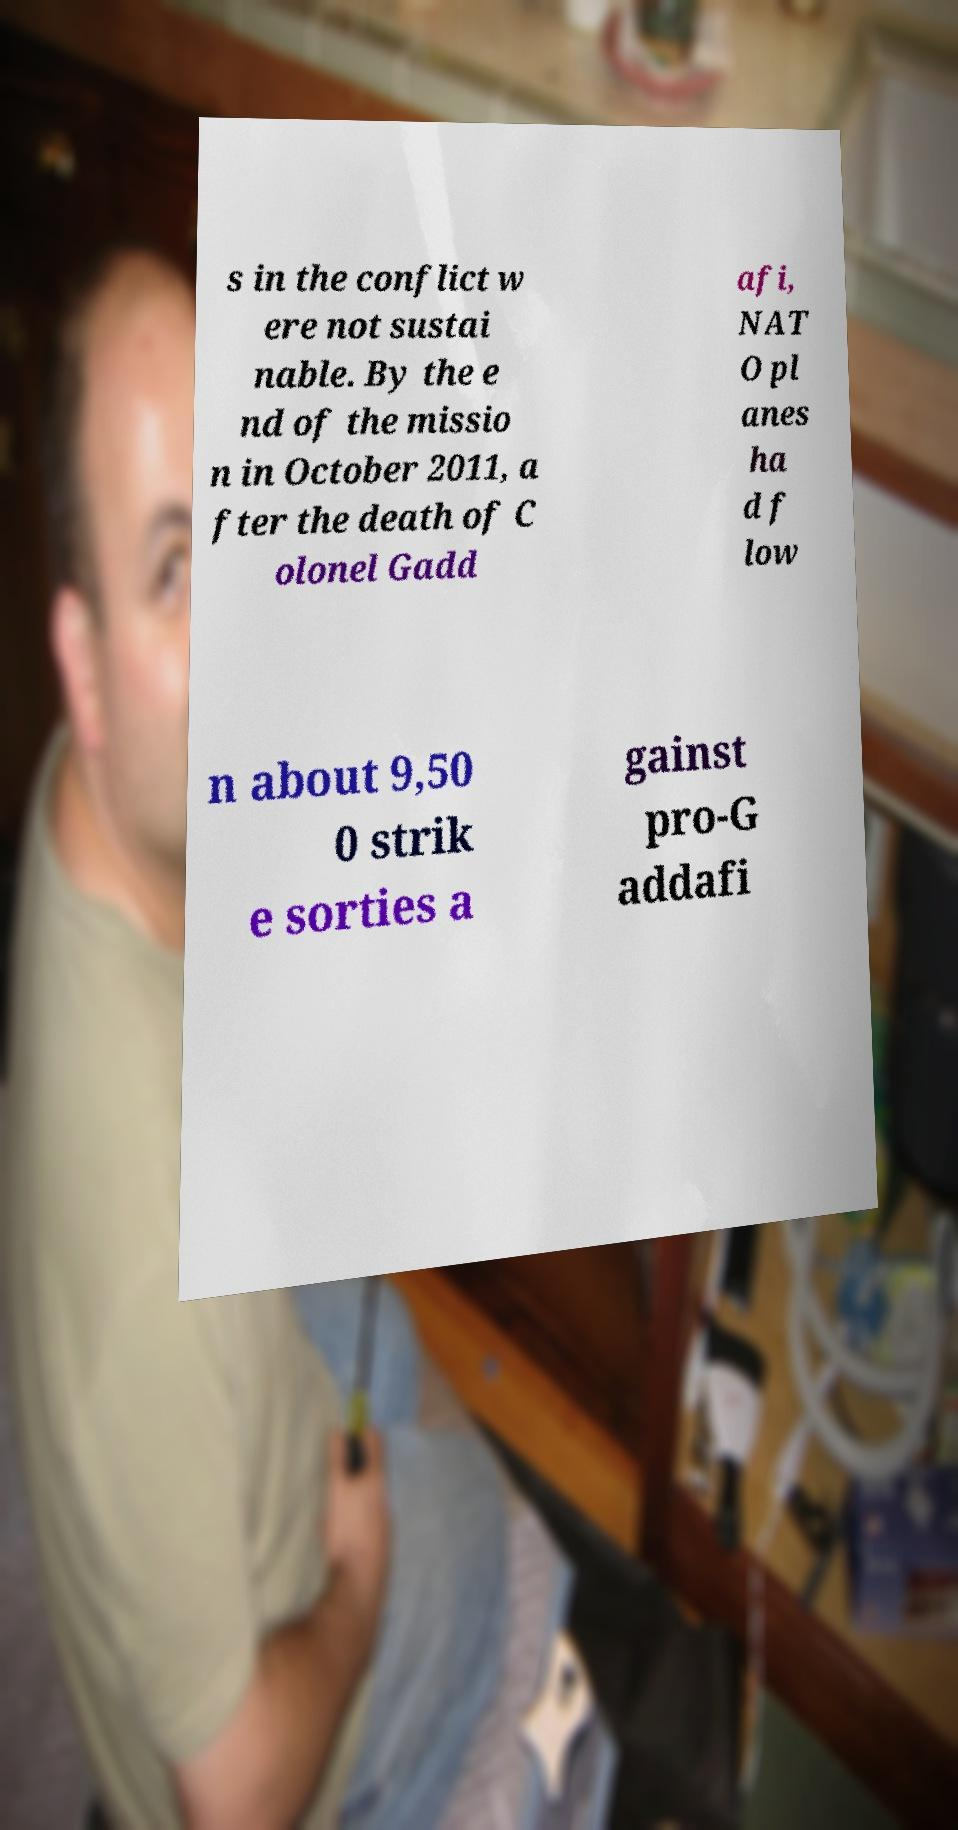For documentation purposes, I need the text within this image transcribed. Could you provide that? s in the conflict w ere not sustai nable. By the e nd of the missio n in October 2011, a fter the death of C olonel Gadd afi, NAT O pl anes ha d f low n about 9,50 0 strik e sorties a gainst pro-G addafi 